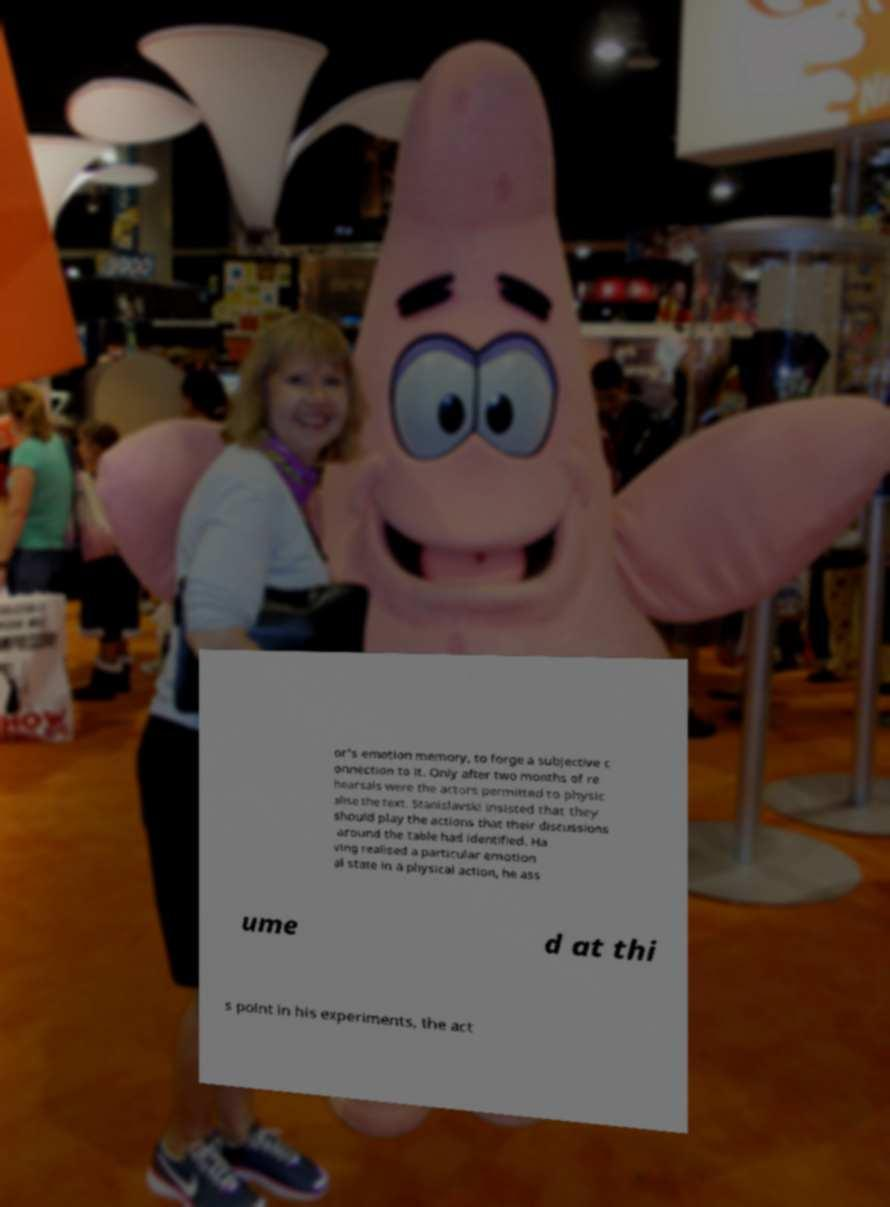Please read and relay the text visible in this image. What does it say? or's emotion memory, to forge a subjective c onnection to it. Only after two months of re hearsals were the actors permitted to physic alise the text. Stanislavski insisted that they should play the actions that their discussions around the table had identified. Ha ving realised a particular emotion al state in a physical action, he ass ume d at thi s point in his experiments, the act 